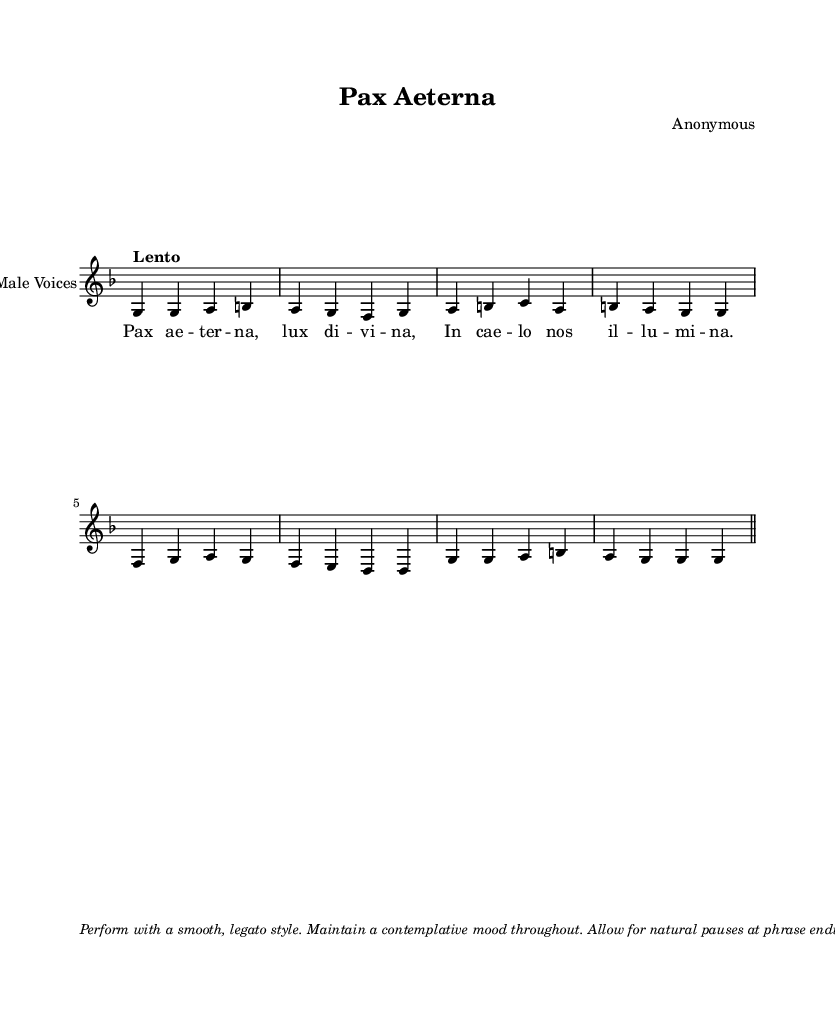What is the title of this piece? The title is indicated at the top of the sheet music header. The word "Pax Aeterna" is present there, making it the title of this composition.
Answer: Pax Aeterna What is the key signature of this music? The key signature is found in the initial measures, where a "G" is indicated along with "dorian." This signifies that the piece is in the G Dorian mode, which has one flat.
Answer: G Dorian What is the time signature of this composition? The time signature is displayed near the beginning of the score. It is shown as "4/4," which indicates that there are four beats per measure and the quarter note gets one beat.
Answer: 4/4 What is the tempo marking for the performance? The tempo is specified in the score with the word "Lento," suggesting a slow pace for the performance. This provides guidance on how the piece should be played.
Answer: Lento How many measures are in the melody? The melody section contains eight measures total, which can be counted directly from the beginning to the end of the melody line before the marker indicating the end of the piece.
Answer: Eight What is the dynamic marking for the performance? The performance instructions indicate a dynamic level of "mp" throughout the piece. This means "mezzo piano," suggesting a moderately soft volume for the music.
Answer: mp What does the term "legato" indicate for the performance? The term "legato" is used in the performance instructions and indicates that the notes should be played smoothly and connected, without any noticeable breaks between them.
Answer: Smooth 